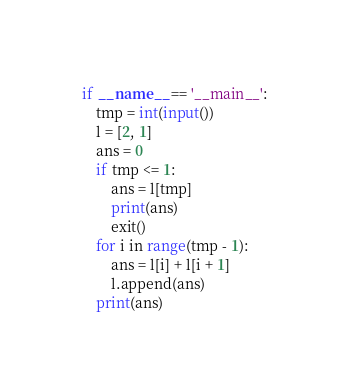<code> <loc_0><loc_0><loc_500><loc_500><_Python_>
if __name__ == '__main__':
    tmp = int(input())
    l = [2, 1]
    ans = 0
    if tmp <= 1:
        ans = l[tmp]
        print(ans)
        exit()
    for i in range(tmp - 1):
        ans = l[i] + l[i + 1]
        l.append(ans)
    print(ans)</code> 